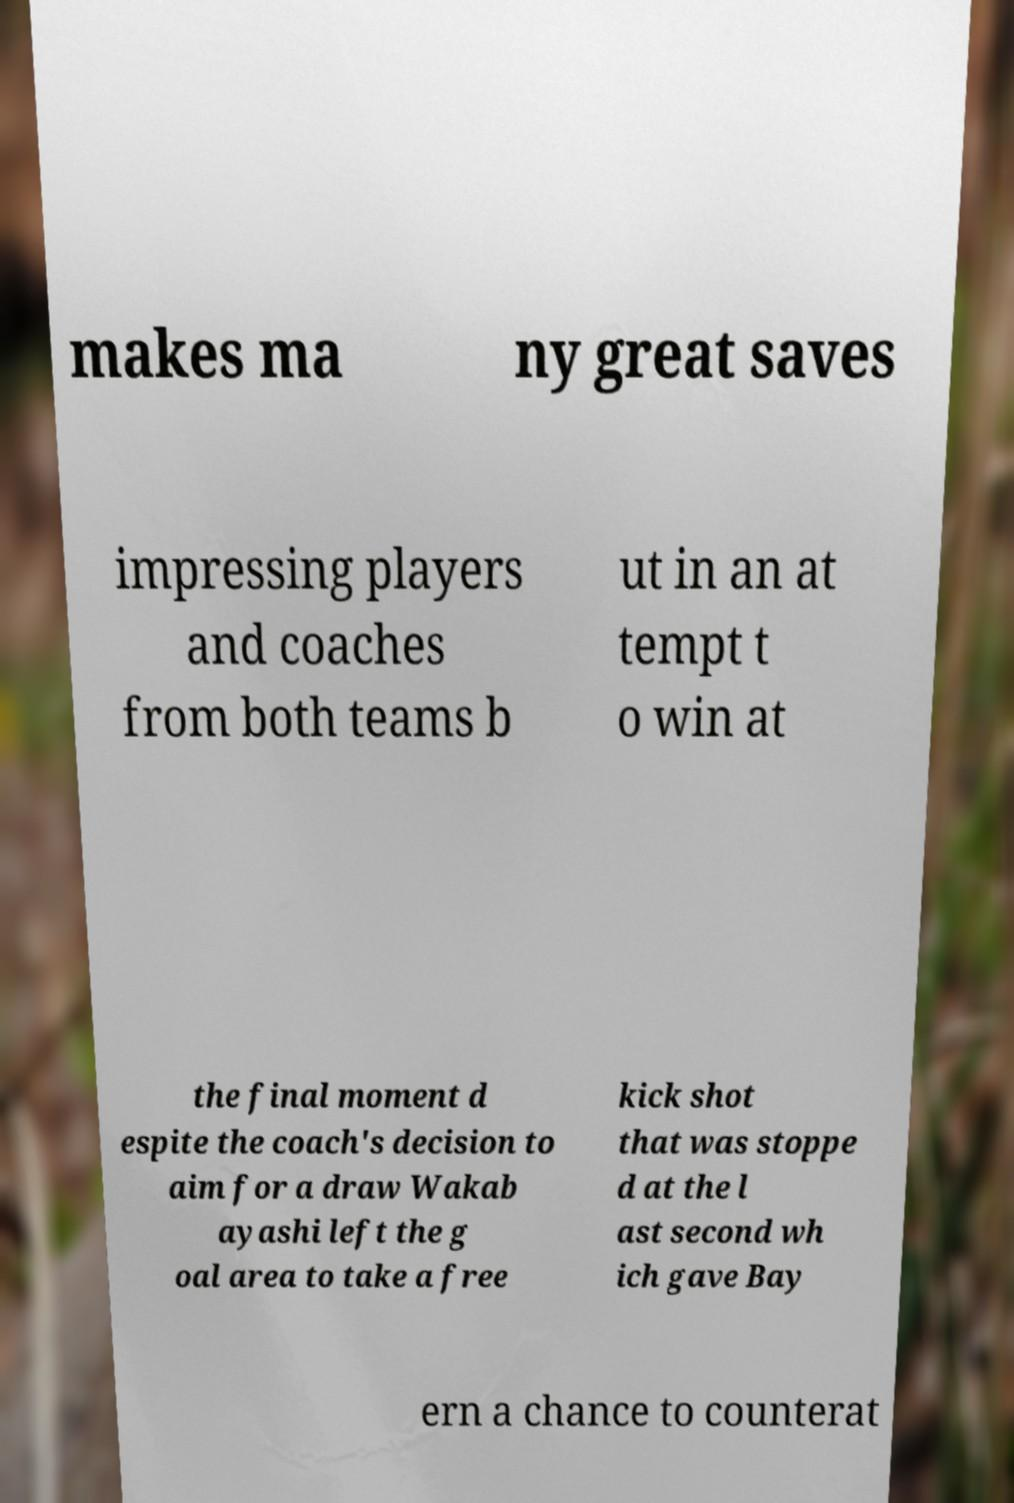Please identify and transcribe the text found in this image. makes ma ny great saves impressing players and coaches from both teams b ut in an at tempt t o win at the final moment d espite the coach's decision to aim for a draw Wakab ayashi left the g oal area to take a free kick shot that was stoppe d at the l ast second wh ich gave Bay ern a chance to counterat 